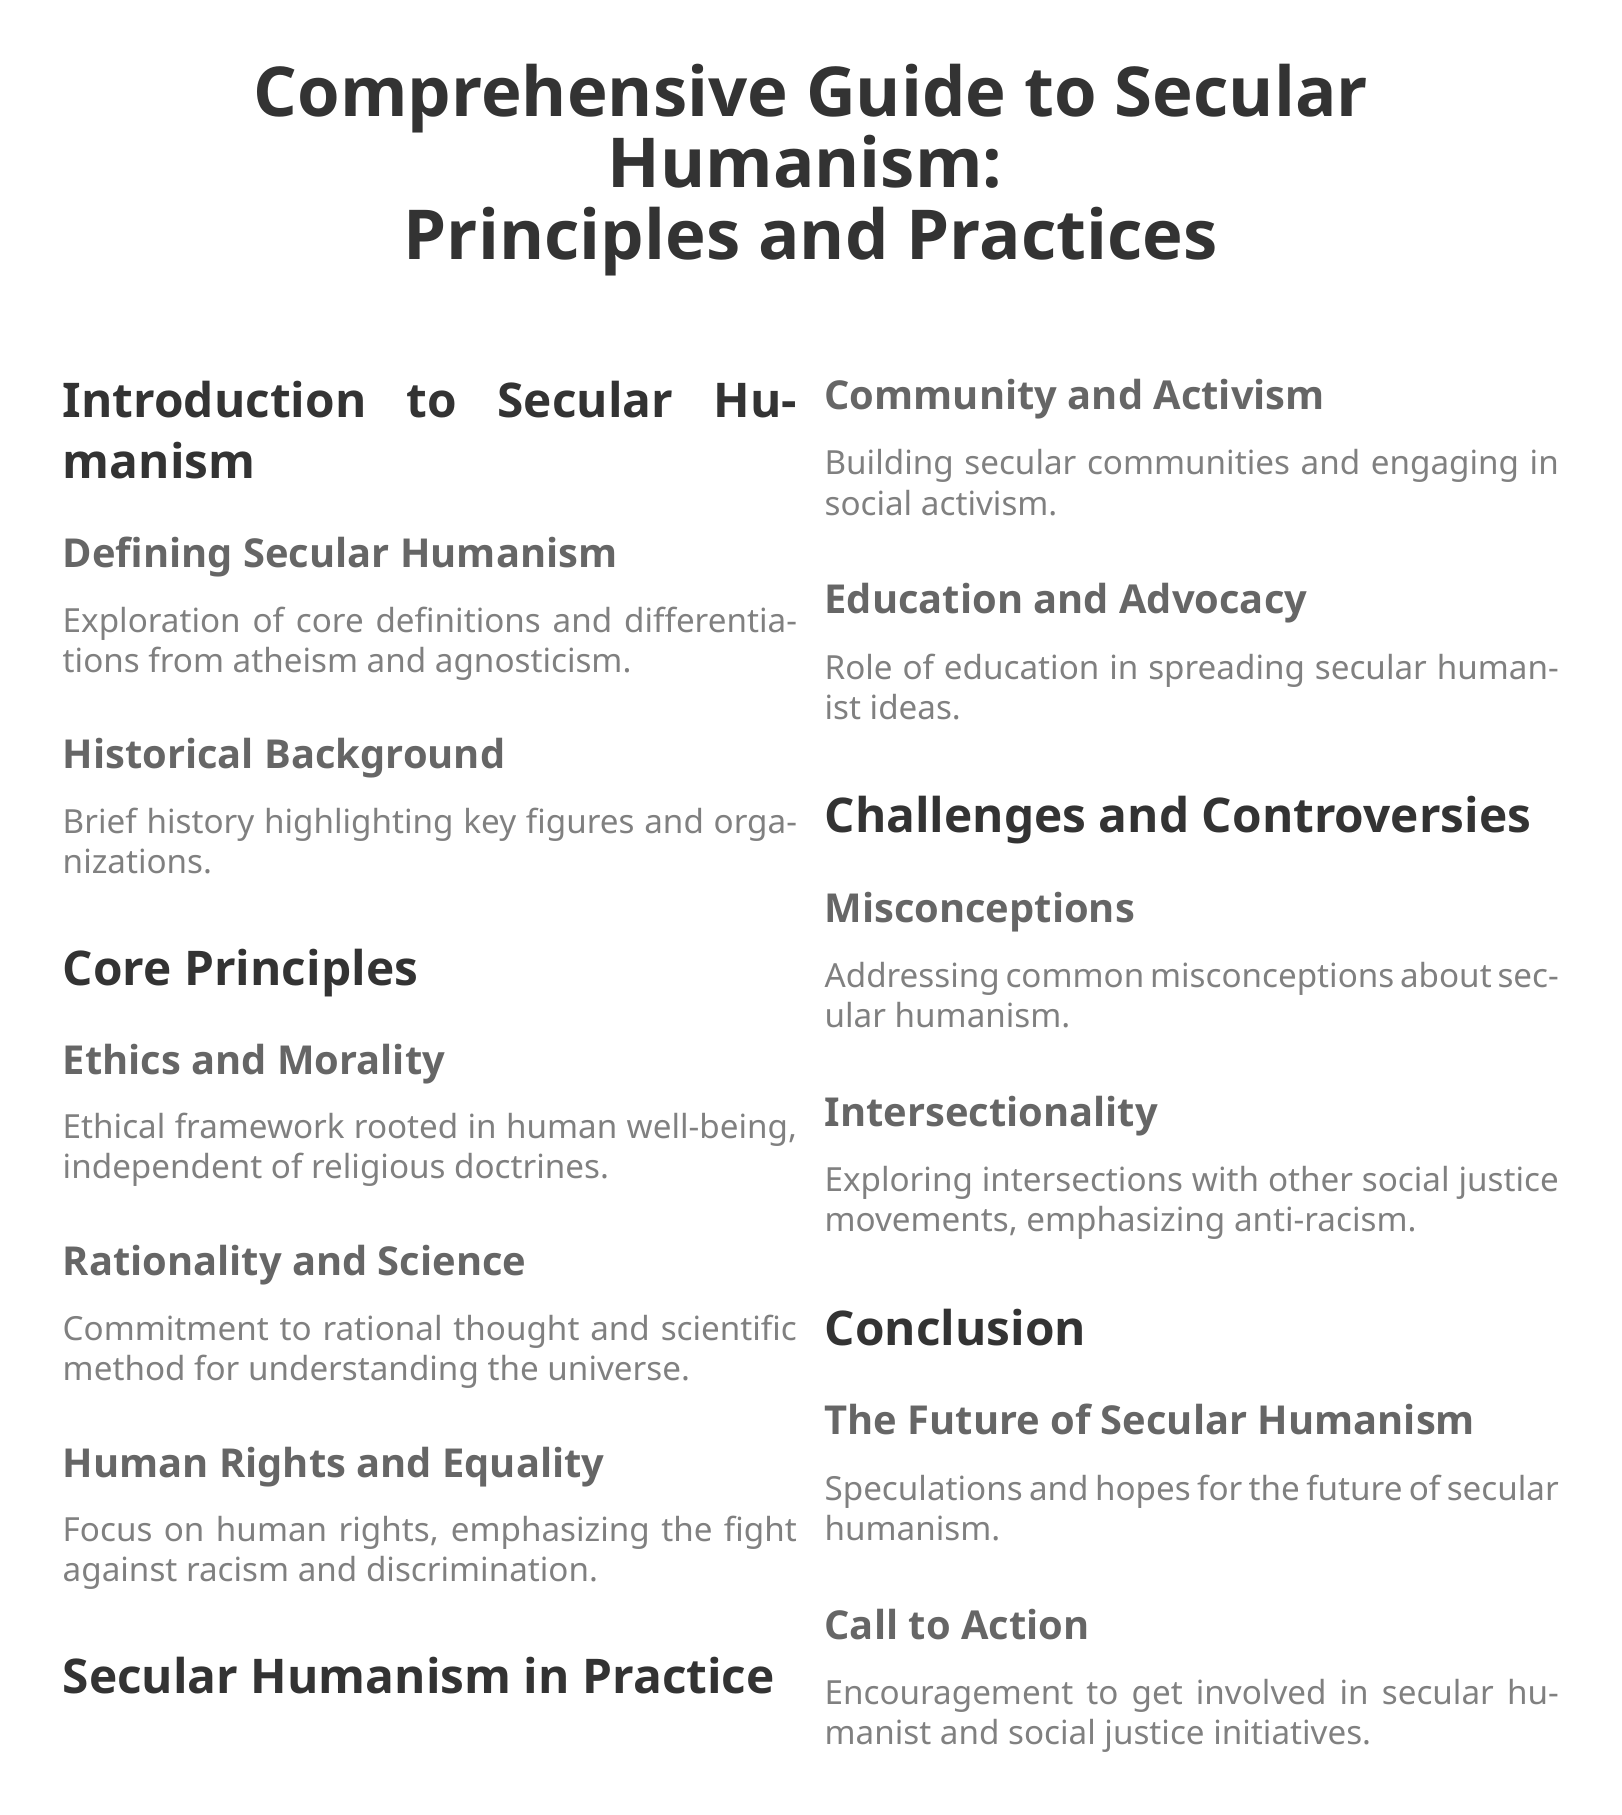What is the main focus of Secular Humanism? The document states the core focus of Secular Humanism is on human rights, emphasizing the fight against racism and discrimination.
Answer: Human rights and equality Who are the key figures associated with Secular Humanism? The document refers to a brief history that highlights key figures, though it does not specify them in the index.
Answer: Not specified What ethical framework does Secular Humanism rely on? The document mentions that the ethical framework of Secular Humanism is rooted in human well-being, independent of religious doctrines.
Answer: Human well-being What is the role of education in Secular Humanism? It is mentioned in the document that education plays a crucial role in spreading secular humanist ideas.
Answer: Spreading secular humanist ideas Which section addresses misconceptions about Secular Humanism? The document specifies a section dedicated to addressing common misconceptions about secular humanism.
Answer: Misconceptions How does Secular Humanism approach social activism? The document highlights engaging in social activism as part of building secular communities.
Answer: Community and activism What does the conclusion emphasize for the future? The document states that the conclusion speculates and hopes for the future of secular humanism.
Answer: Future of Secular Humanism What does the section on intersectionality explore? The document mentions that the section explores intersections with other social justice movements, emphasizing anti-racism.
Answer: Anti-racism What is a specific call to action in the document? The document encourages involvement in secular humanist and social justice initiatives as a call to action.
Answer: Get involved in initiatives 